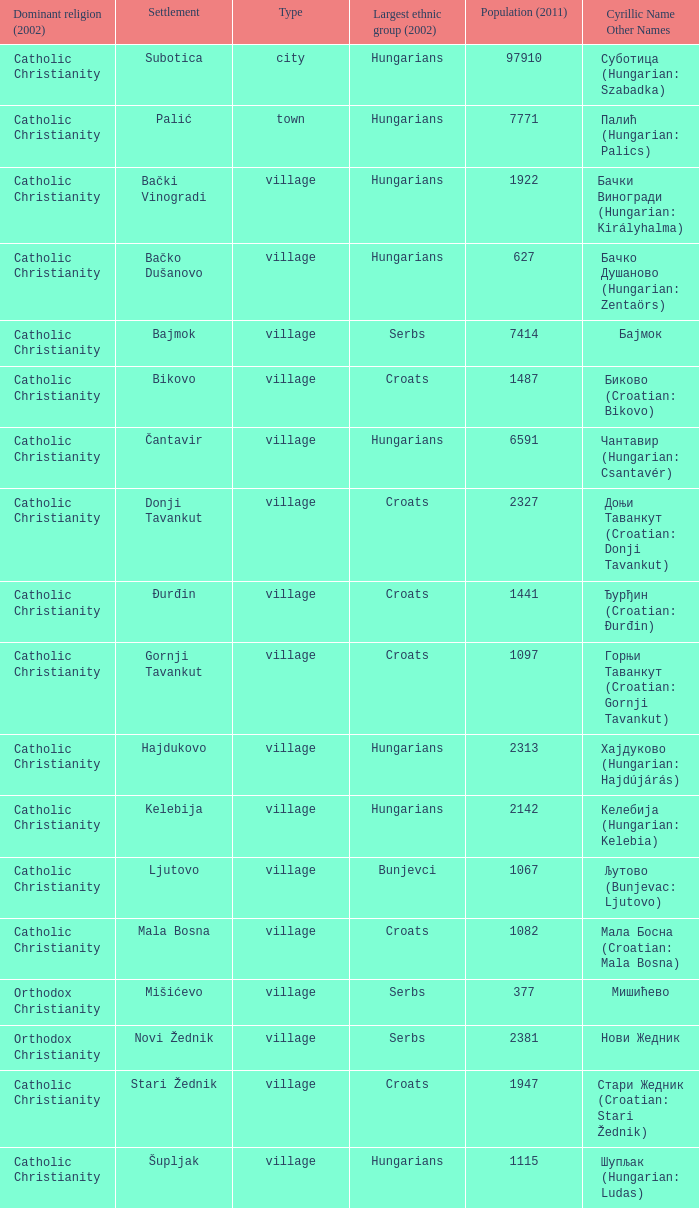What is the population in стари жедник (croatian: stari žednik)? 1947.0. 